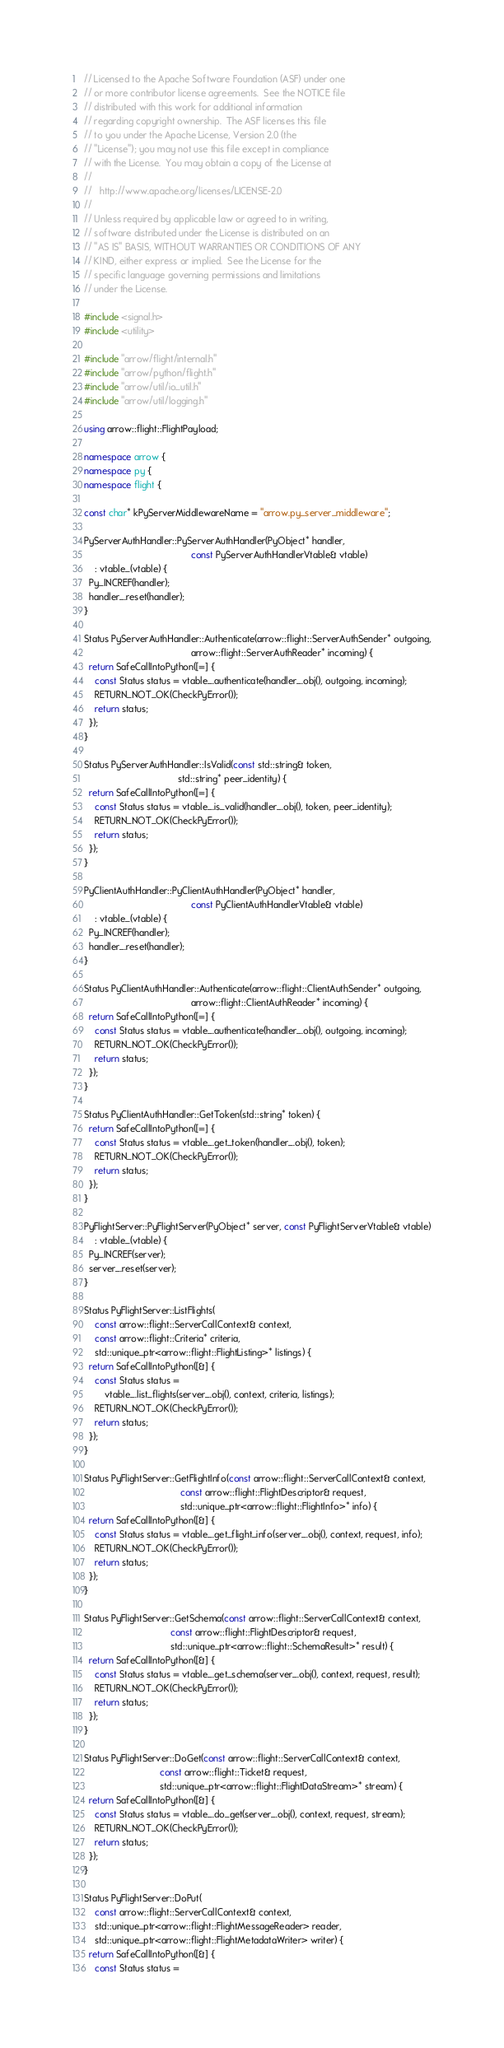Convert code to text. <code><loc_0><loc_0><loc_500><loc_500><_C++_>// Licensed to the Apache Software Foundation (ASF) under one
// or more contributor license agreements.  See the NOTICE file
// distributed with this work for additional information
// regarding copyright ownership.  The ASF licenses this file
// to you under the Apache License, Version 2.0 (the
// "License"); you may not use this file except in compliance
// with the License.  You may obtain a copy of the License at
//
//   http://www.apache.org/licenses/LICENSE-2.0
//
// Unless required by applicable law or agreed to in writing,
// software distributed under the License is distributed on an
// "AS IS" BASIS, WITHOUT WARRANTIES OR CONDITIONS OF ANY
// KIND, either express or implied.  See the License for the
// specific language governing permissions and limitations
// under the License.

#include <signal.h>
#include <utility>

#include "arrow/flight/internal.h"
#include "arrow/python/flight.h"
#include "arrow/util/io_util.h"
#include "arrow/util/logging.h"

using arrow::flight::FlightPayload;

namespace arrow {
namespace py {
namespace flight {

const char* kPyServerMiddlewareName = "arrow.py_server_middleware";

PyServerAuthHandler::PyServerAuthHandler(PyObject* handler,
                                         const PyServerAuthHandlerVtable& vtable)
    : vtable_(vtable) {
  Py_INCREF(handler);
  handler_.reset(handler);
}

Status PyServerAuthHandler::Authenticate(arrow::flight::ServerAuthSender* outgoing,
                                         arrow::flight::ServerAuthReader* incoming) {
  return SafeCallIntoPython([=] {
    const Status status = vtable_.authenticate(handler_.obj(), outgoing, incoming);
    RETURN_NOT_OK(CheckPyError());
    return status;
  });
}

Status PyServerAuthHandler::IsValid(const std::string& token,
                                    std::string* peer_identity) {
  return SafeCallIntoPython([=] {
    const Status status = vtable_.is_valid(handler_.obj(), token, peer_identity);
    RETURN_NOT_OK(CheckPyError());
    return status;
  });
}

PyClientAuthHandler::PyClientAuthHandler(PyObject* handler,
                                         const PyClientAuthHandlerVtable& vtable)
    : vtable_(vtable) {
  Py_INCREF(handler);
  handler_.reset(handler);
}

Status PyClientAuthHandler::Authenticate(arrow::flight::ClientAuthSender* outgoing,
                                         arrow::flight::ClientAuthReader* incoming) {
  return SafeCallIntoPython([=] {
    const Status status = vtable_.authenticate(handler_.obj(), outgoing, incoming);
    RETURN_NOT_OK(CheckPyError());
    return status;
  });
}

Status PyClientAuthHandler::GetToken(std::string* token) {
  return SafeCallIntoPython([=] {
    const Status status = vtable_.get_token(handler_.obj(), token);
    RETURN_NOT_OK(CheckPyError());
    return status;
  });
}

PyFlightServer::PyFlightServer(PyObject* server, const PyFlightServerVtable& vtable)
    : vtable_(vtable) {
  Py_INCREF(server);
  server_.reset(server);
}

Status PyFlightServer::ListFlights(
    const arrow::flight::ServerCallContext& context,
    const arrow::flight::Criteria* criteria,
    std::unique_ptr<arrow::flight::FlightListing>* listings) {
  return SafeCallIntoPython([&] {
    const Status status =
        vtable_.list_flights(server_.obj(), context, criteria, listings);
    RETURN_NOT_OK(CheckPyError());
    return status;
  });
}

Status PyFlightServer::GetFlightInfo(const arrow::flight::ServerCallContext& context,
                                     const arrow::flight::FlightDescriptor& request,
                                     std::unique_ptr<arrow::flight::FlightInfo>* info) {
  return SafeCallIntoPython([&] {
    const Status status = vtable_.get_flight_info(server_.obj(), context, request, info);
    RETURN_NOT_OK(CheckPyError());
    return status;
  });
}

Status PyFlightServer::GetSchema(const arrow::flight::ServerCallContext& context,
                                 const arrow::flight::FlightDescriptor& request,
                                 std::unique_ptr<arrow::flight::SchemaResult>* result) {
  return SafeCallIntoPython([&] {
    const Status status = vtable_.get_schema(server_.obj(), context, request, result);
    RETURN_NOT_OK(CheckPyError());
    return status;
  });
}

Status PyFlightServer::DoGet(const arrow::flight::ServerCallContext& context,
                             const arrow::flight::Ticket& request,
                             std::unique_ptr<arrow::flight::FlightDataStream>* stream) {
  return SafeCallIntoPython([&] {
    const Status status = vtable_.do_get(server_.obj(), context, request, stream);
    RETURN_NOT_OK(CheckPyError());
    return status;
  });
}

Status PyFlightServer::DoPut(
    const arrow::flight::ServerCallContext& context,
    std::unique_ptr<arrow::flight::FlightMessageReader> reader,
    std::unique_ptr<arrow::flight::FlightMetadataWriter> writer) {
  return SafeCallIntoPython([&] {
    const Status status =</code> 